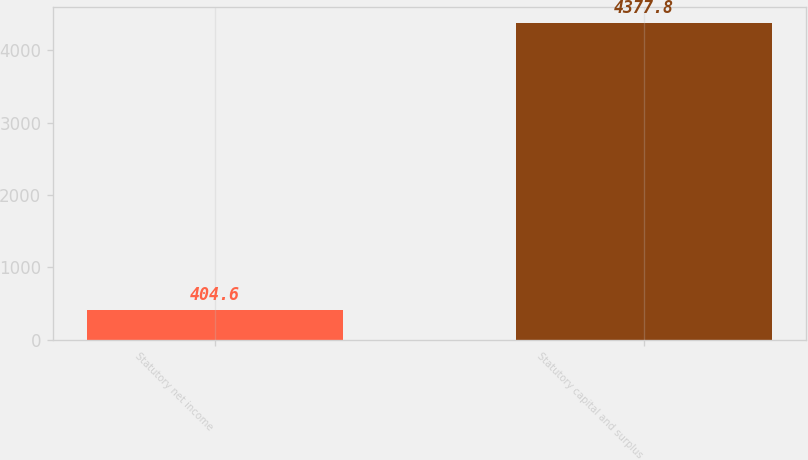Convert chart. <chart><loc_0><loc_0><loc_500><loc_500><bar_chart><fcel>Statutory net income<fcel>Statutory capital and surplus<nl><fcel>404.6<fcel>4377.8<nl></chart> 